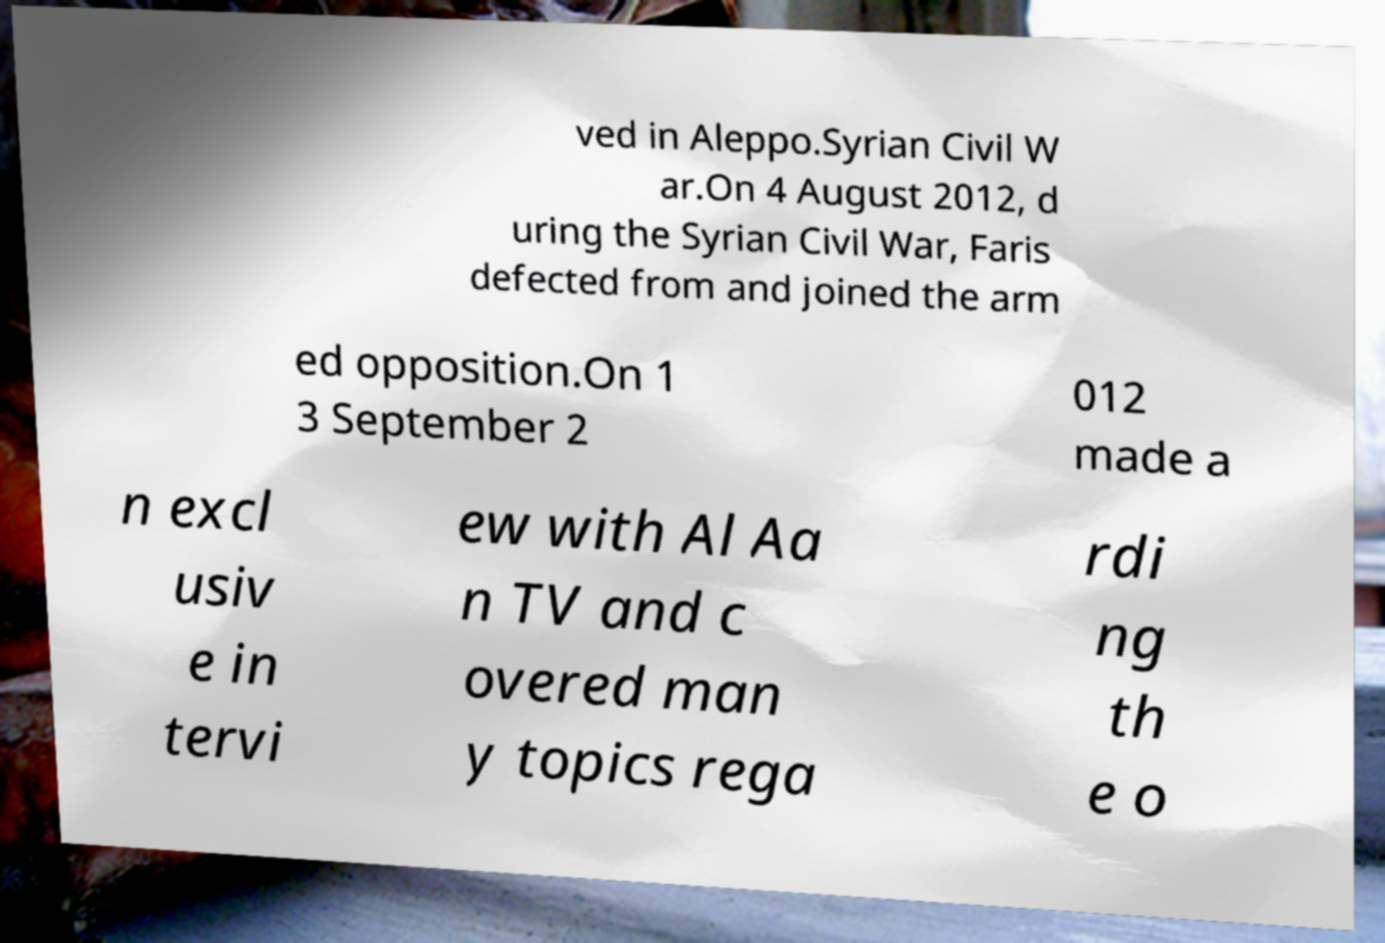Can you read and provide the text displayed in the image?This photo seems to have some interesting text. Can you extract and type it out for me? ved in Aleppo.Syrian Civil W ar.On 4 August 2012, d uring the Syrian Civil War, Faris defected from and joined the arm ed opposition.On 1 3 September 2 012 made a n excl usiv e in tervi ew with Al Aa n TV and c overed man y topics rega rdi ng th e o 